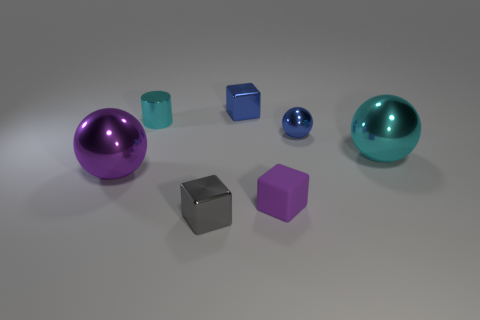What is the color of the other metal object that is the same shape as the gray object?
Keep it short and to the point. Blue. The blue metallic ball has what size?
Provide a succinct answer. Small. How many blue shiny objects have the same size as the purple matte thing?
Offer a very short reply. 2. Is the sphere to the left of the purple rubber block made of the same material as the purple object that is to the right of the gray object?
Provide a succinct answer. No. Are there more small metal cylinders than small metallic blocks?
Offer a terse response. No. Is there anything else that is the same color as the tiny cylinder?
Offer a terse response. Yes. Do the small gray block and the tiny purple block have the same material?
Your answer should be compact. No. Is the number of tiny metal cylinders less than the number of tiny yellow blocks?
Make the answer very short. No. Do the large cyan metal thing and the big purple shiny object have the same shape?
Your response must be concise. Yes. The small rubber cube has what color?
Offer a very short reply. Purple. 